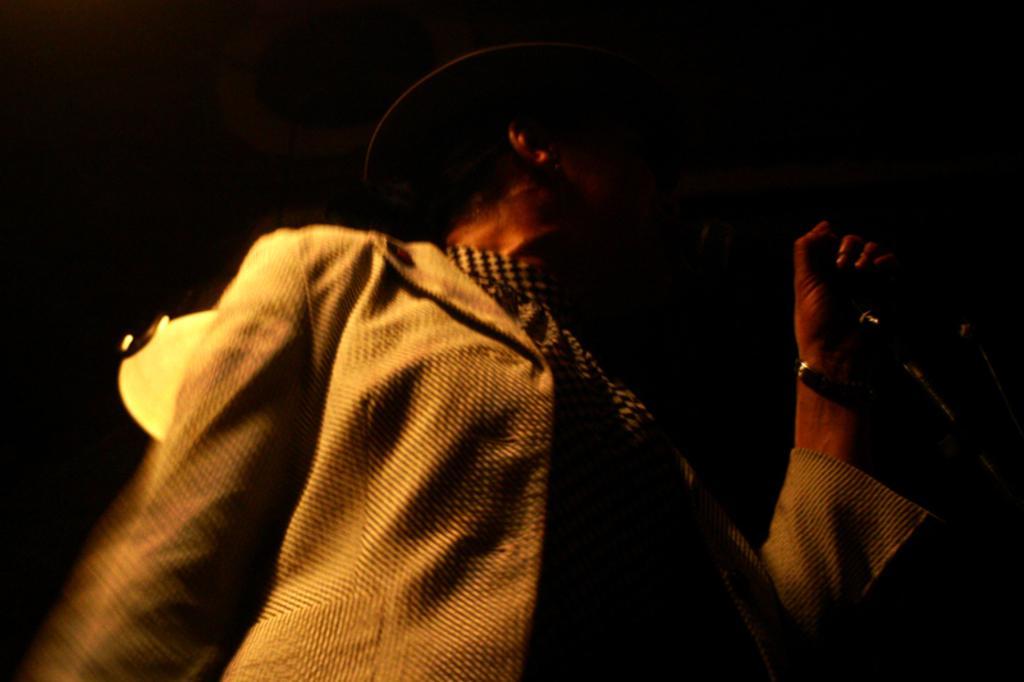How would you summarize this image in a sentence or two? In this picture we can see women wore jacket, scarf to her neck and cap on her head standing and giving gesture and in background we can see light and here it is so dark. 